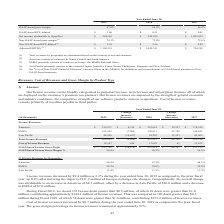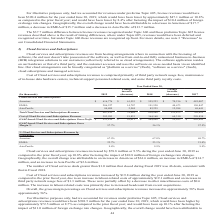According to Opentext Corporation's financial document, How much did Cost of license revenues increase by in the year ended June 30, 2019 as compared to the prior fiscal year? According to the financial document, $0.7 million. The relevant text states: "Cost of license revenues increased by $0.7 million during the year ended June 30, 2019 as compared to the prior fiscal year. The gross margin percentag..." Also, During Fiscal 2019, how much deals greater than $1.0 million were closed? According to the financial document, 49 deals. The relevant text states: "license deals greater than $0.5 million, of which 49 deals were greater than $1.0 million, contributing approximately $144.1 million of license revenues. This..." Also, What was the change increase in License revenues for Americas for 2018 to 2019? According to the financial document, $8,216 (in thousands). The relevant text states: "Americas $ 215,871 $ 8,216 $ 207,655 $ 29,257 $ 178,398..." Also, can you calculate: What is the percentage decrease of Total License Revenues from 2018 to 2019? Based on the calculation: 9,420/437,512, the result is 2.15 (percentage). This is based on the information: "Total License Revenues 428,092 (9,420) 437,512 68,368 369,144 Total License Revenues 428,092 (9,420) 437,512 68,368 369,144..." The key data points involved are: 437,512, 9,420. Also, can you calculate: For 2019. what is the Cost of License Revenues expressed as a percentage of GAAP-based License Gross Profit?  Based on the calculation: 14,347/413,745, the result is 3.47 (percentage). This is based on the information: "GAAP-based License Gross Profit $ 413,745 $ (10,074) $ 423,819 $ 68,307 $ 355,512 Cost of License Revenues 14,347 654 13,693 61 13,632..." The key data points involved are: 14,347, 413,745. Also, can you calculate: What is the average annual GAAP-based License Gross Profit for the 3 years? To answer this question, I need to perform calculations using the financial data. The calculation is: (413,745+423,819+355,512)/3, which equals 397692 (in thousands). This is based on the information: "GAAP-based License Gross Profit $ 413,745 $ (10,074) $ 423,819 $ 68,307 $ 355,512 Profit $ 413,745 $ (10,074) $ 423,819 $ 68,307 $ 355,512 based License Gross Profit $ 413,745 $ (10,074) $ 423,819 $ 6..." The key data points involved are: 355,512, 413,745, 423,819. 